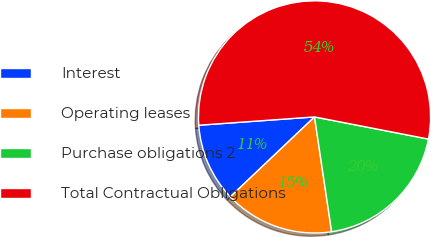<chart> <loc_0><loc_0><loc_500><loc_500><pie_chart><fcel>Interest<fcel>Operating leases<fcel>Purchase obligations 2<fcel>Total Contractual Obligations<nl><fcel>10.94%<fcel>15.27%<fcel>19.59%<fcel>54.2%<nl></chart> 